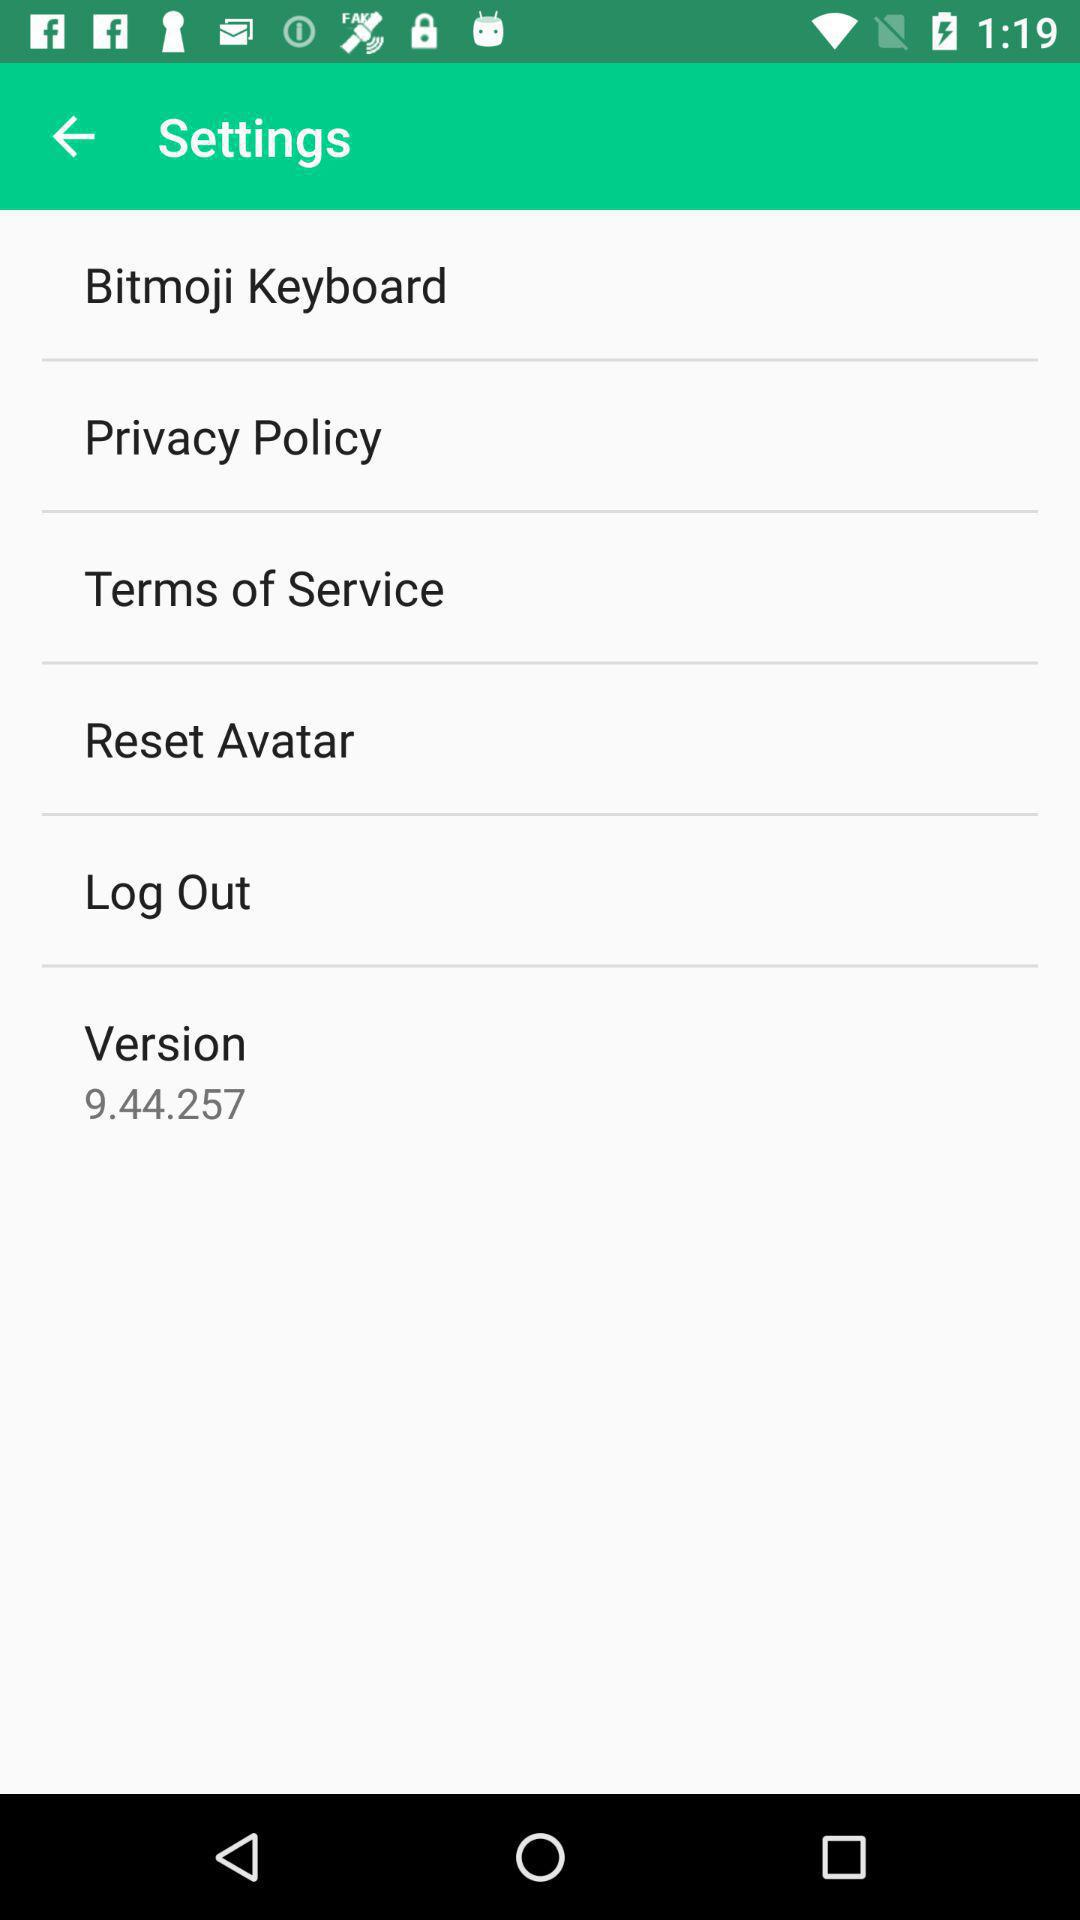What is the version? The version is 9.44.257. 